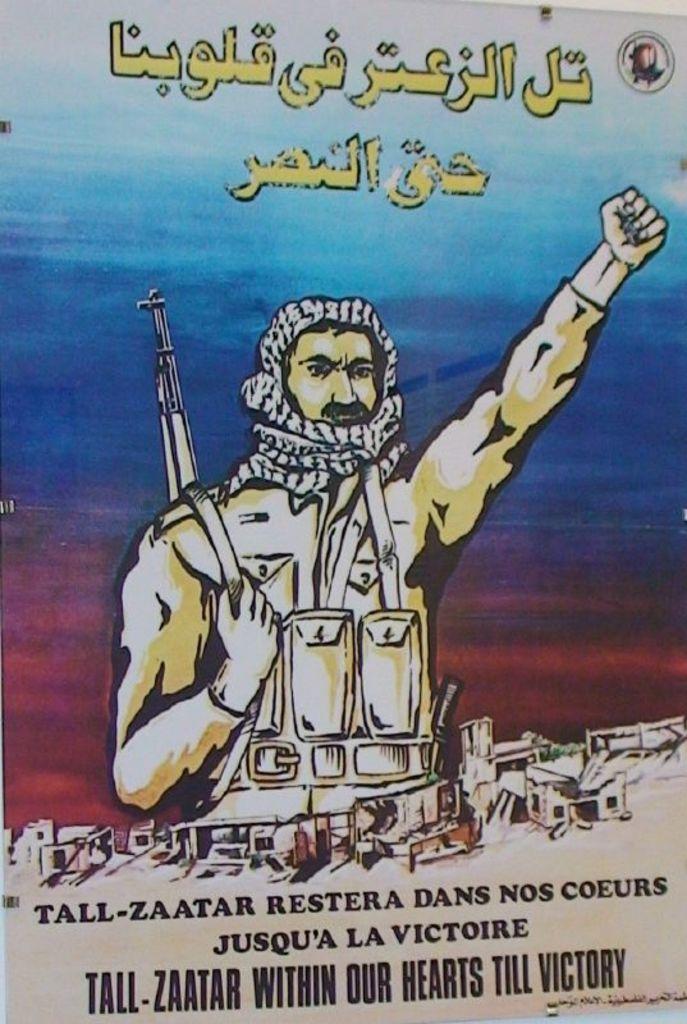Zaatar will be within their hearts until when?
Make the answer very short. Till victory. 